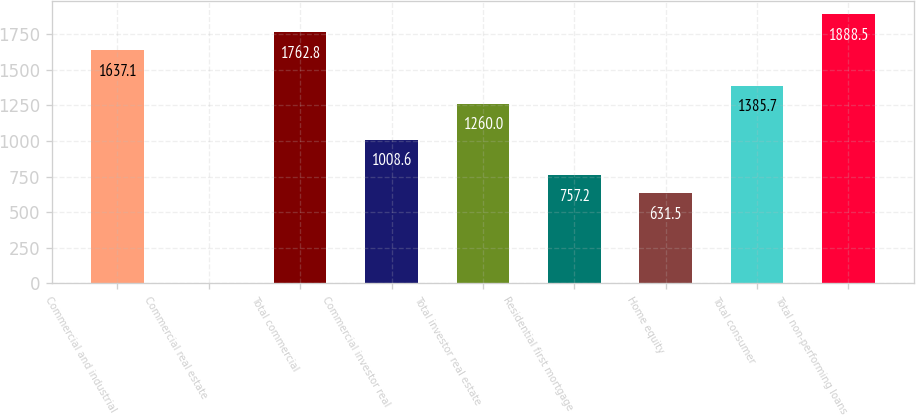Convert chart. <chart><loc_0><loc_0><loc_500><loc_500><bar_chart><fcel>Commercial and industrial<fcel>Commercial real estate<fcel>Total commercial<fcel>Commercial investor real<fcel>Total investor real estate<fcel>Residential first mortgage<fcel>Home equity<fcel>Total consumer<fcel>Total non-performing loans<nl><fcel>1637.1<fcel>3<fcel>1762.8<fcel>1008.6<fcel>1260<fcel>757.2<fcel>631.5<fcel>1385.7<fcel>1888.5<nl></chart> 